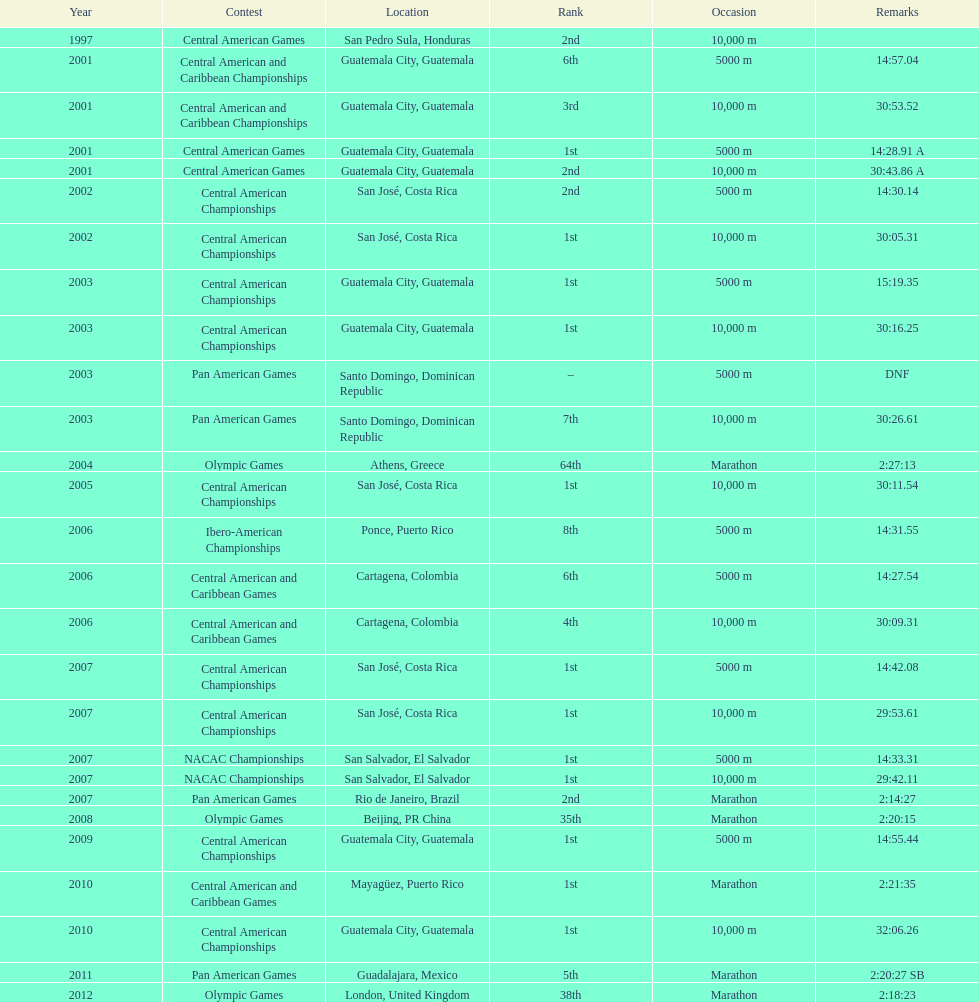How many times has this athlete not finished in a competition? 1. 